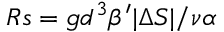<formula> <loc_0><loc_0><loc_500><loc_500>R s = { g d ^ { 3 } \beta ^ { \prime } | \Delta S | } / { \nu \alpha }</formula> 